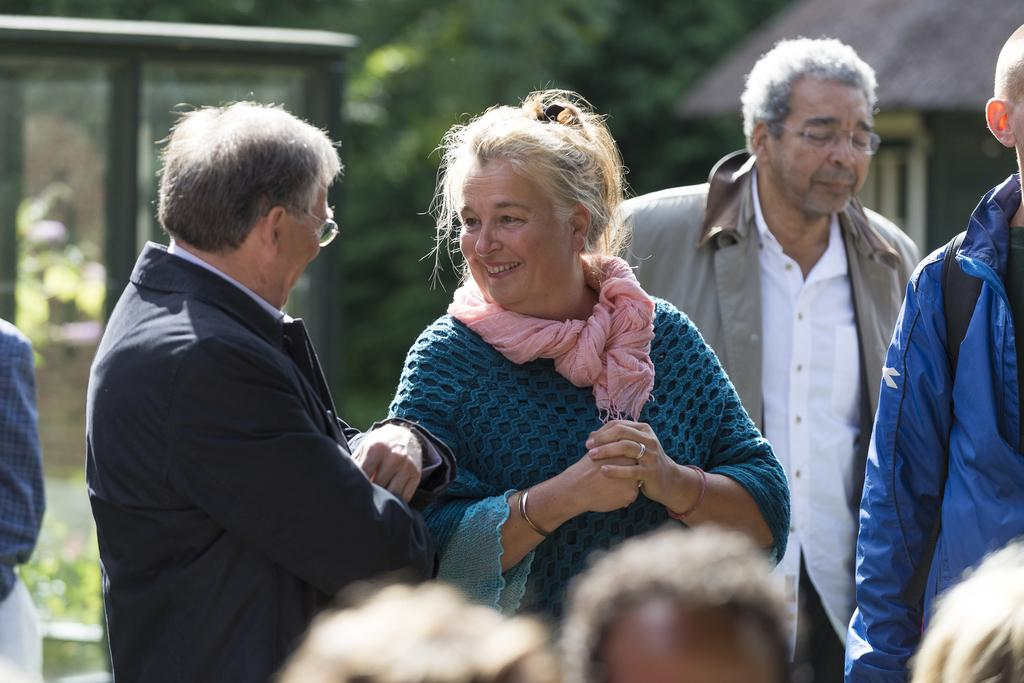How many people are in the image? There is a group of persons in the image. What can be seen in the background of the image? There is a hut, plants, trees, and a glass object in the background of the image. How is the background of the image depicted? The background of the image is blurred. What type of pizzas are being served to the laborer in the image? There are no pizzas or laborers present in the image. What kind of bait is being used to catch fish in the image? There is no fishing or bait depicted in the image. 